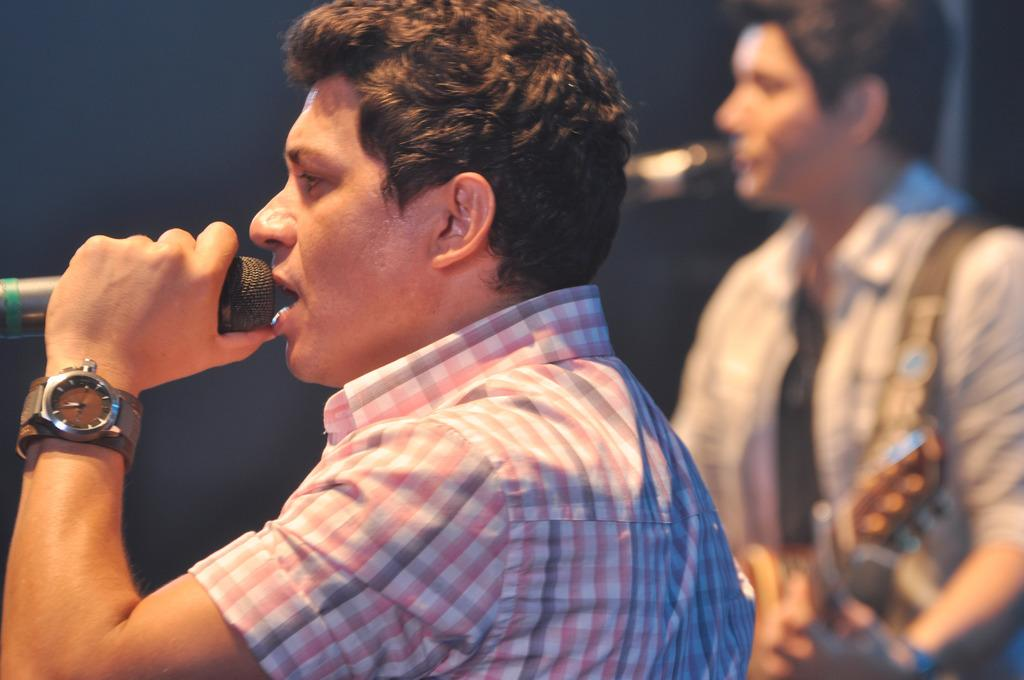What is the man in the image holding? The man is holding a microphone in the image. What is the man doing with the microphone? The man is singing while holding the microphone. Can you describe the other person in the image? There is another man in the background of the image, and he is holding a guitar. What type of hat is the expert wearing in the image? There is no expert or hat present in the image. 